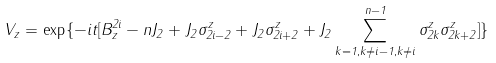Convert formula to latex. <formula><loc_0><loc_0><loc_500><loc_500>V _ { z } = \exp \{ - i t [ B _ { z } ^ { 2 i } - n J _ { 2 } + J _ { 2 } \sigma _ { 2 i - 2 } ^ { z } + J _ { 2 } \sigma _ { 2 i + 2 } ^ { z } + J _ { 2 } \sum _ { k = 1 , k \neq i - 1 , k \neq i } ^ { n - 1 } \sigma _ { 2 k } ^ { z } \sigma _ { 2 k + 2 } ^ { z } ] \}</formula> 